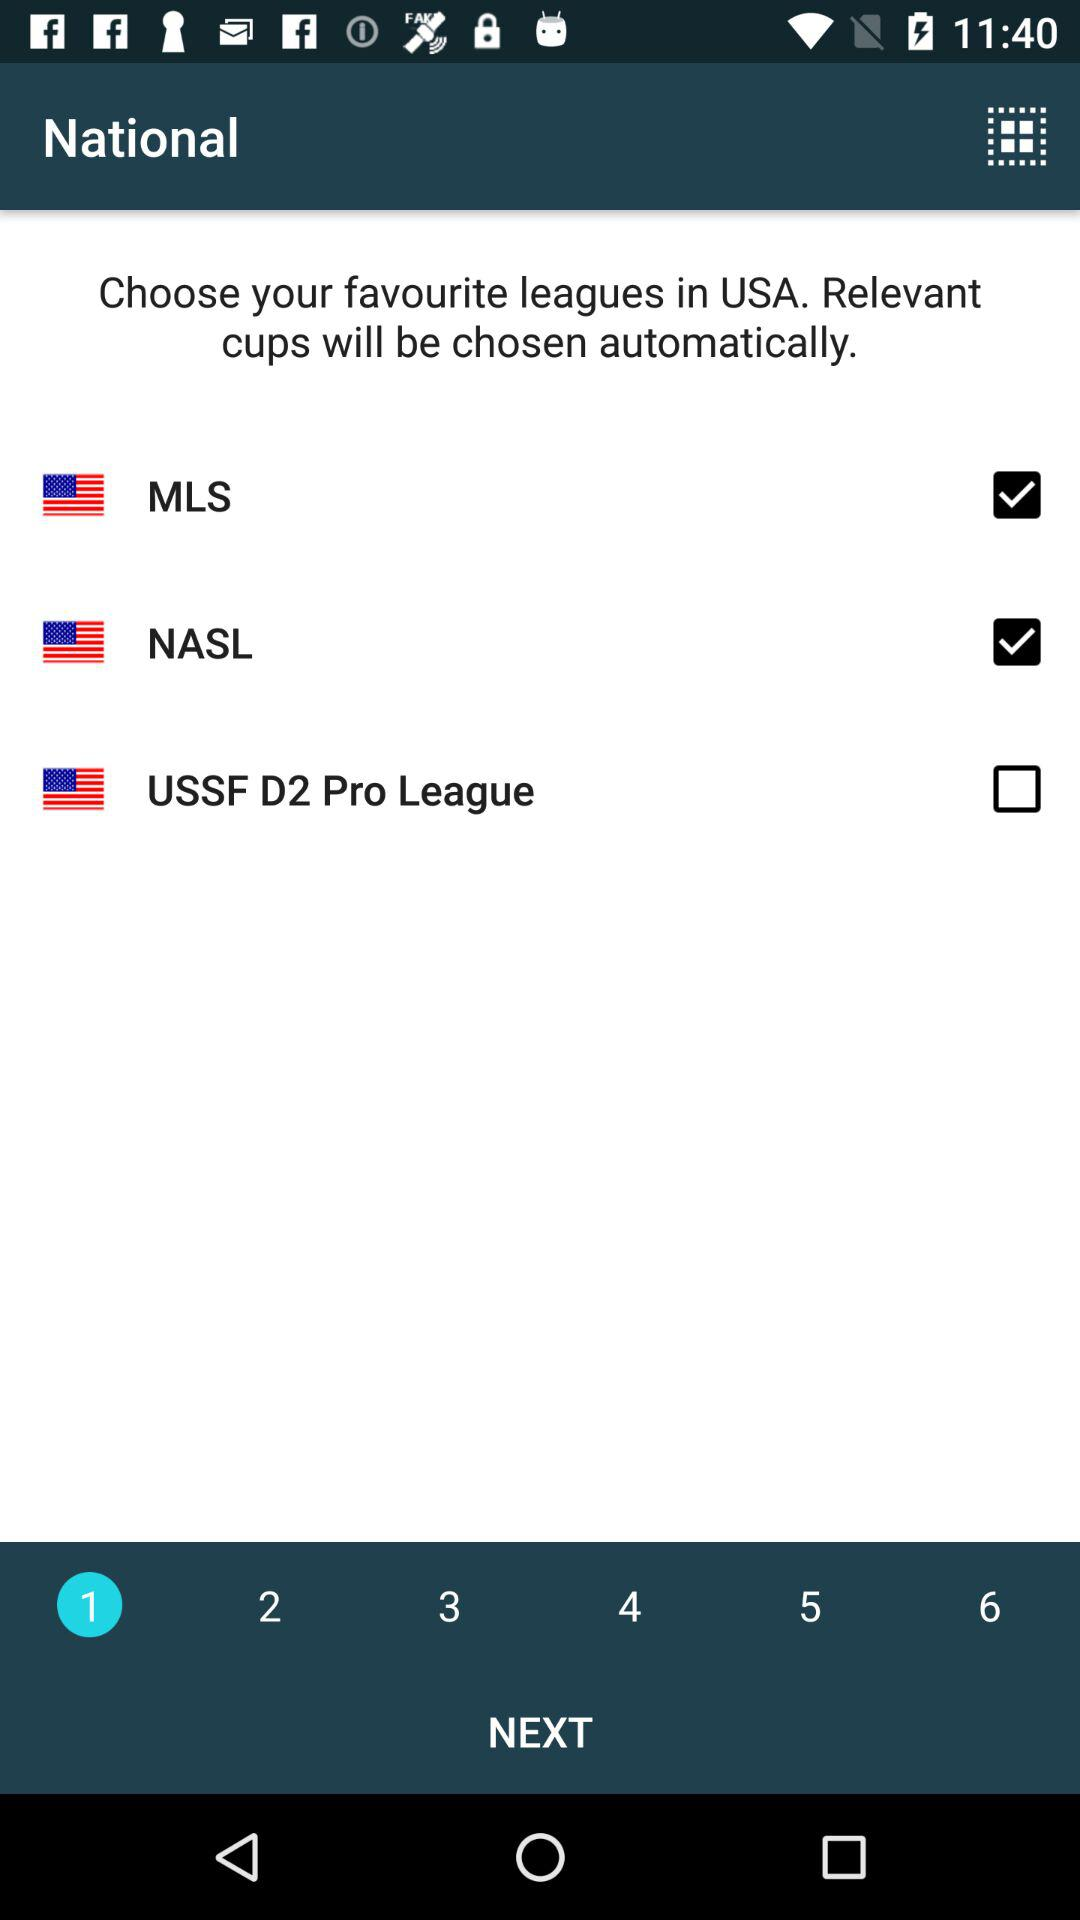How many total steps are there?
When the provided information is insufficient, respond with <no answer>. <no answer> 